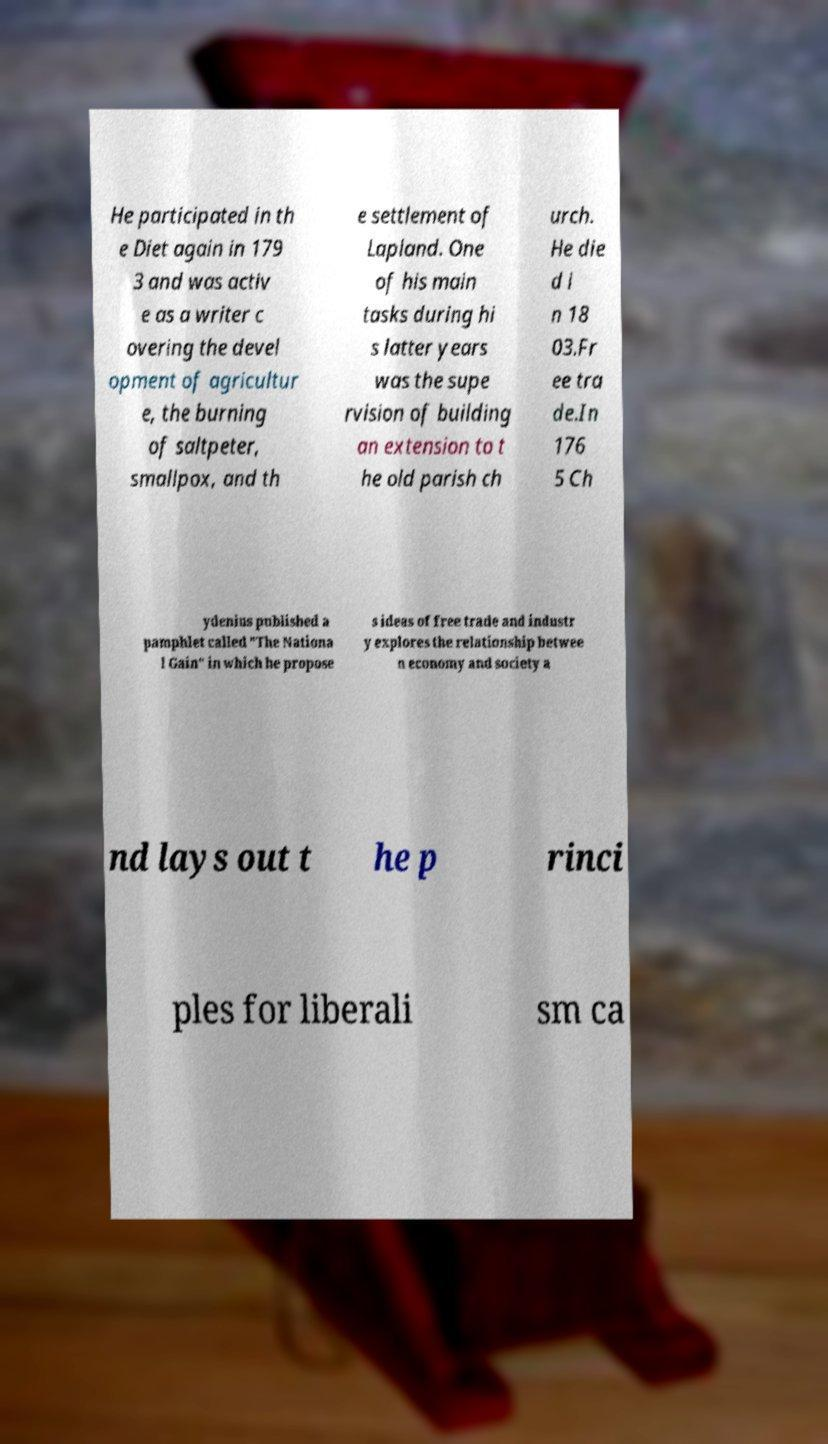There's text embedded in this image that I need extracted. Can you transcribe it verbatim? He participated in th e Diet again in 179 3 and was activ e as a writer c overing the devel opment of agricultur e, the burning of saltpeter, smallpox, and th e settlement of Lapland. One of his main tasks during hi s latter years was the supe rvision of building an extension to t he old parish ch urch. He die d i n 18 03.Fr ee tra de.In 176 5 Ch ydenius published a pamphlet called "The Nationa l Gain" in which he propose s ideas of free trade and industr y explores the relationship betwee n economy and society a nd lays out t he p rinci ples for liberali sm ca 